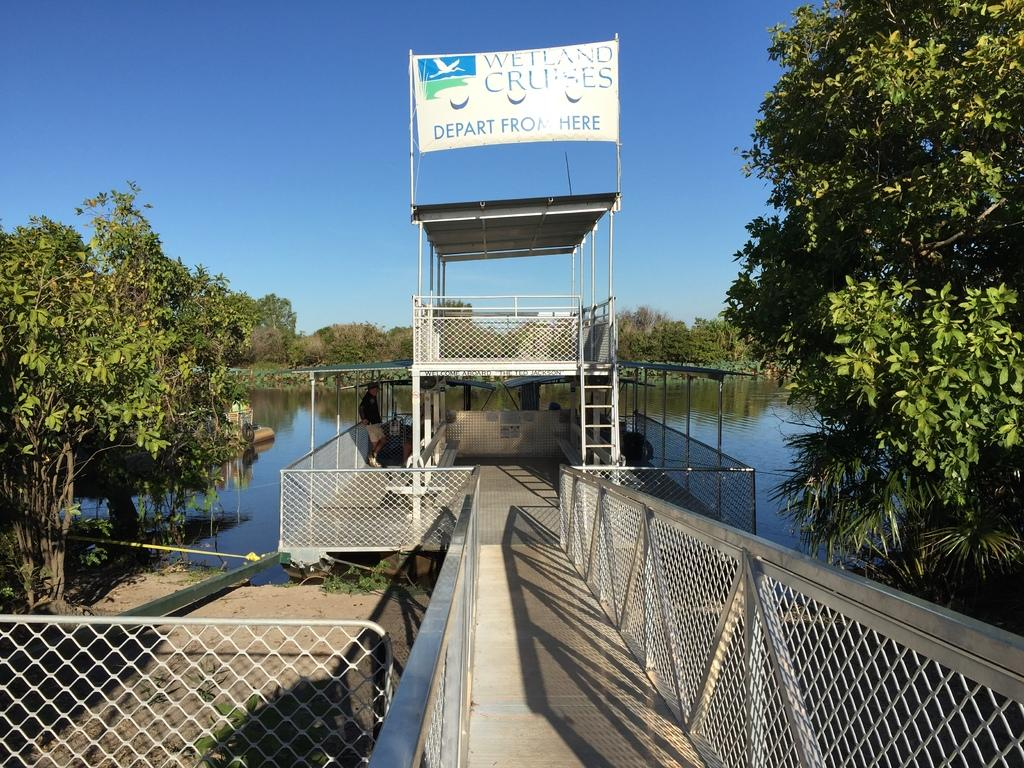What type of bridge is in the center of the image? There is a board bridge in the center of the image. What else is made of boards in the image? There is a board visible in the image. What type of vegetation can be seen in the image? Trees are visible in the image. What is the water in the image used for? The water is present in the image, but its purpose is not specified. What can be seen in the background of the image? The sky is visible in the background of the image. What is at the bottom of the image? There is a mesh at the bottom of the image. How many fish can be seen swimming in the water in the image? There are no fish visible in the image; only a board bridge, board, trees, water, sky, and mesh are present. 